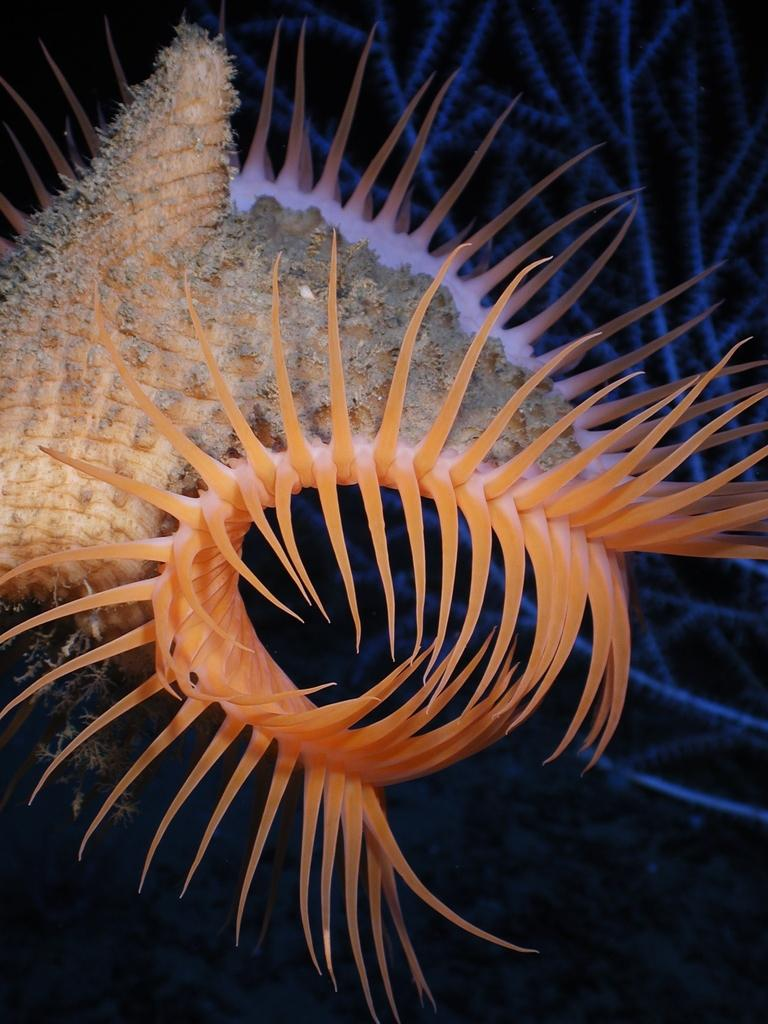What is the color of the object in the image? The object in the image is orange in color. What could the orange object be? The object might be a plant. What else can be seen in the background of the image? There are plants visible in the background of the image. What is the color of the background in the image? The background appears to be black in color. How does the orange object taste in the image? The orange object in the image is not edible, so it cannot be tasted. Is there a sink visible in the image? There is no sink present in the image. 